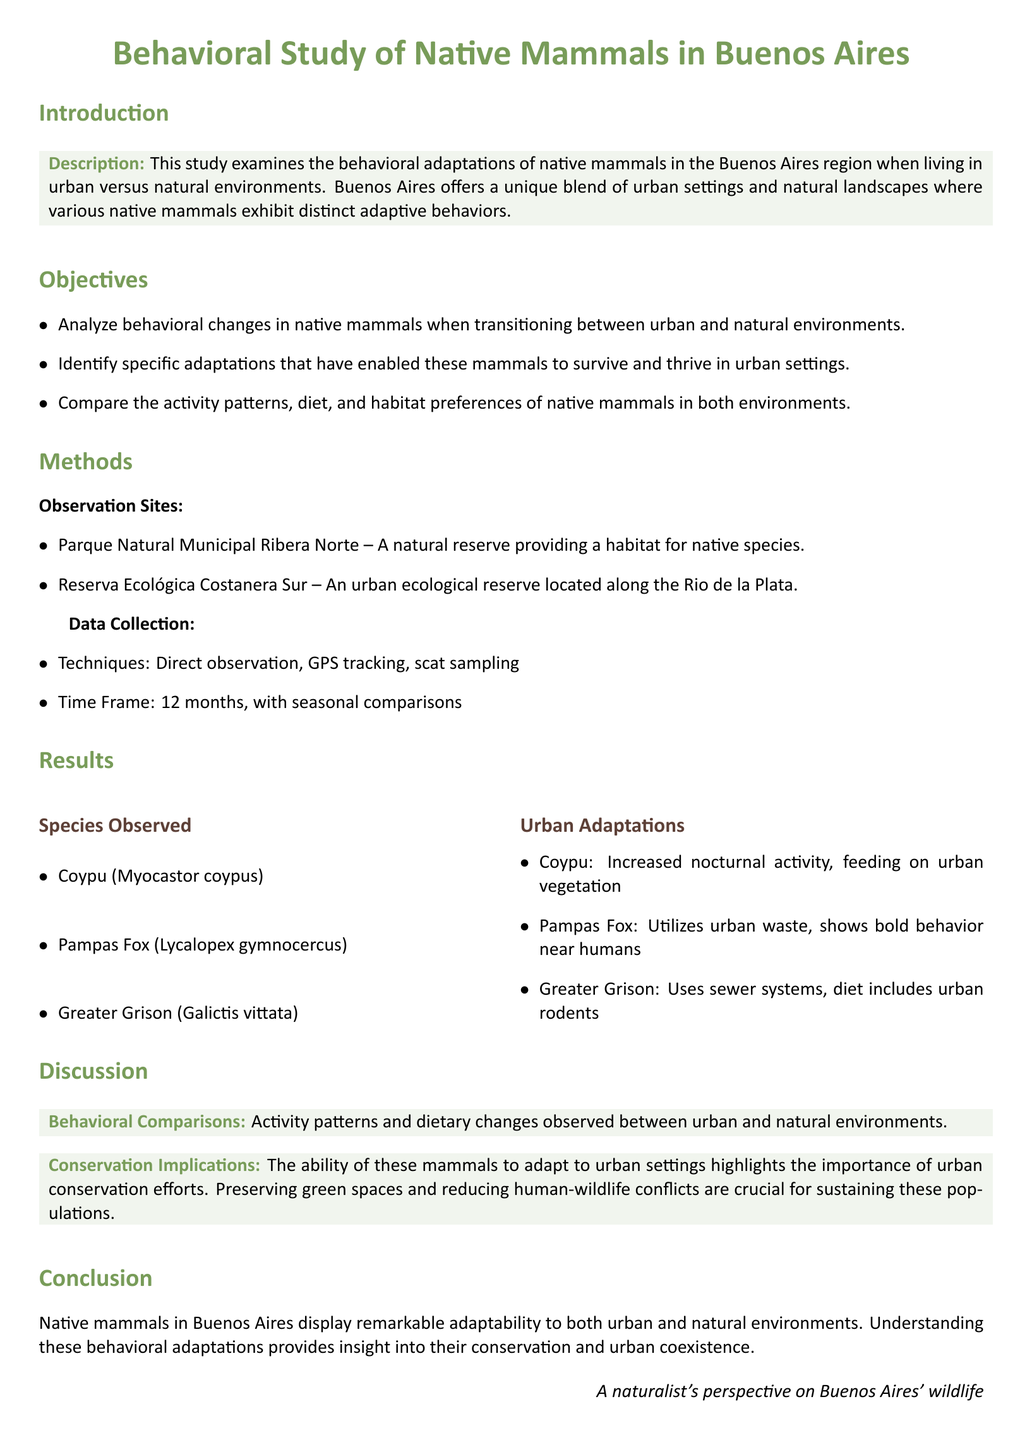What species were observed in the study? The species observed include Coypu, Pampas Fox, and Greater Grison.
Answer: Coypu, Pampas Fox, Greater Grison What was the main objective of the study? The main objective is to analyze behavioral changes in native mammals transitioning between urban and natural environments.
Answer: Analyze behavioral changes What type of data collection techniques were used? The techniques employed for data collection were direct observation, GPS tracking, and scat sampling.
Answer: Direct observation, GPS tracking, scat sampling How long was the study conducted? The study was conducted over a time frame of 12 months.
Answer: 12 months What adaptation was noted for the Coypu in urban environments? The Coypu showed increased nocturnal activity and fed on urban vegetation in urban environments.
Answer: Increased nocturnal activity, urban vegetation What implications does the study suggest for conservation? The study highlights the importance of urban conservation efforts to preserve green spaces and reduce human-wildlife conflicts.
Answer: Urban conservation efforts What two locations served as observation sites? The observation sites were Parque Natural Municipal Ribera Norte and Reserva Ecológica Costanera Sur.
Answer: Parque Natural Municipal Ribera Norte, Reserva Ecológica Costanera Sur What is a unique behavior exhibited by the Pampas Fox? The Pampas Fox utilizes urban waste and shows bold behavior near humans.
Answer: Utilizes urban waste, bold behavior near humans 